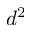<formula> <loc_0><loc_0><loc_500><loc_500>d ^ { 2 }</formula> 